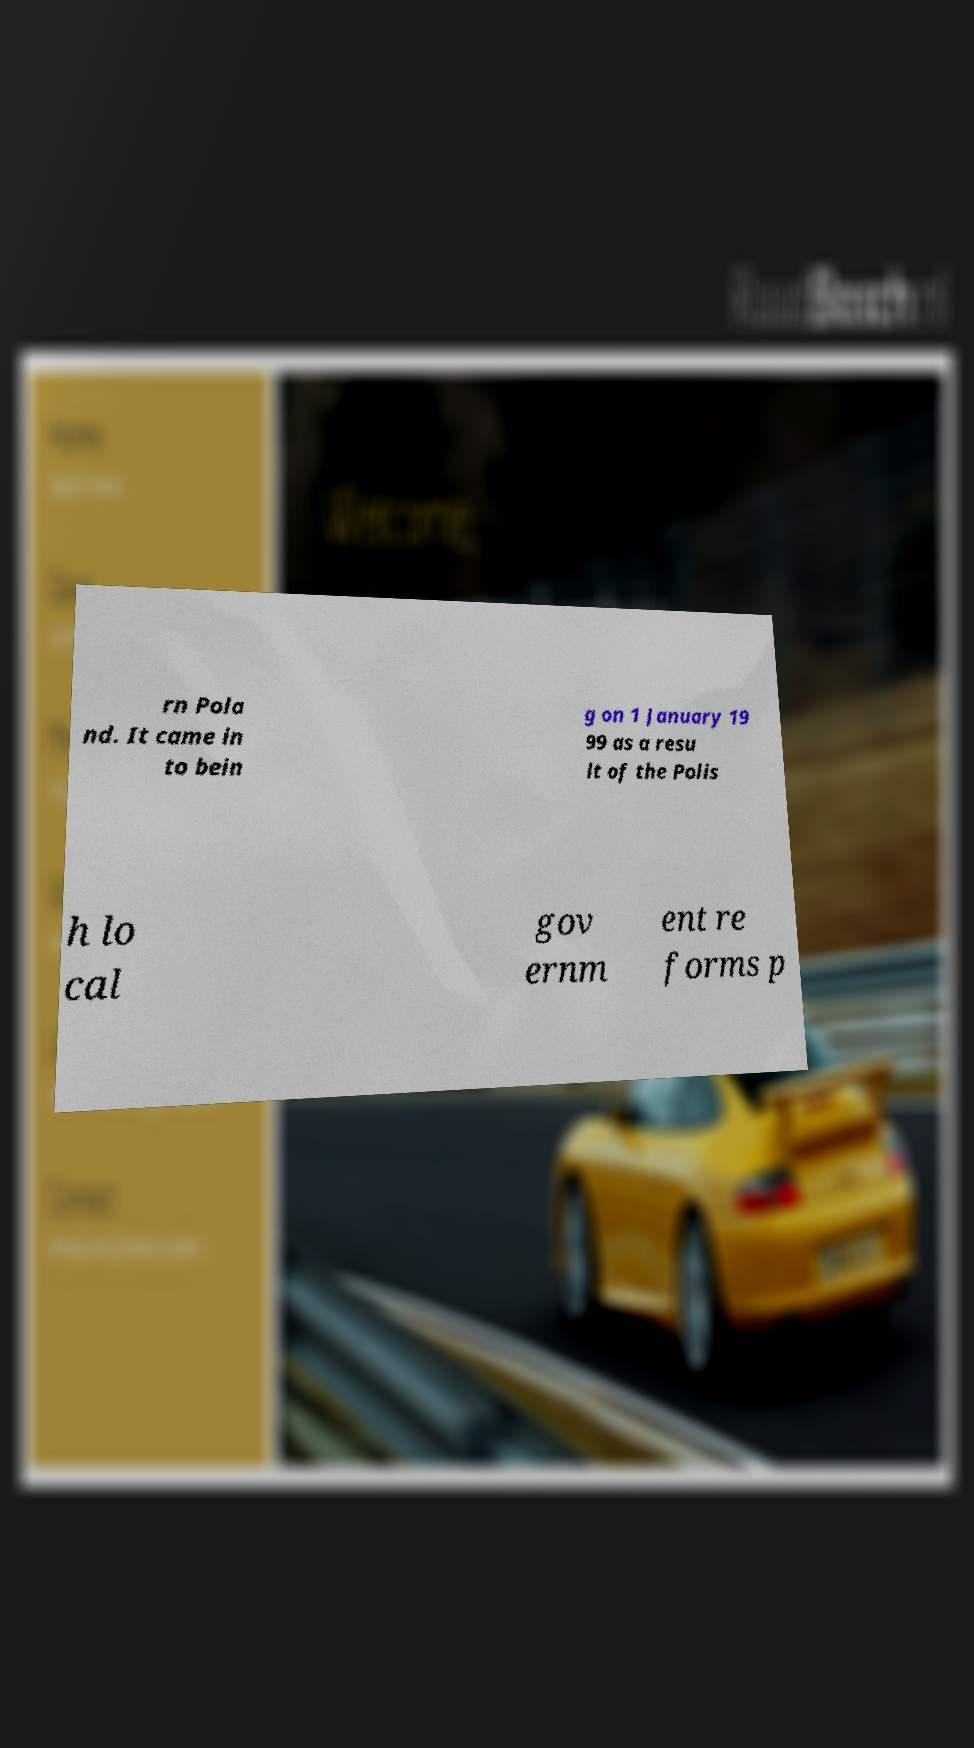Please read and relay the text visible in this image. What does it say? rn Pola nd. It came in to bein g on 1 January 19 99 as a resu lt of the Polis h lo cal gov ernm ent re forms p 